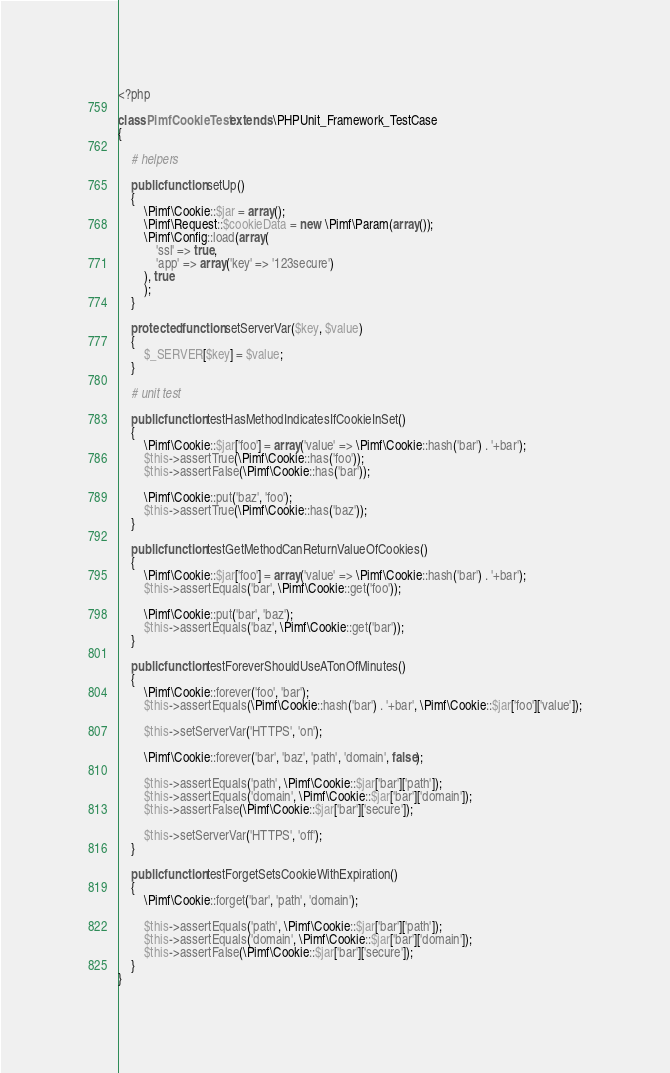Convert code to text. <code><loc_0><loc_0><loc_500><loc_500><_PHP_><?php

class PimfCookieTest extends \PHPUnit_Framework_TestCase
{

    # helpers

    public function setUp()
    {
        \Pimf\Cookie::$jar = array();
        \Pimf\Request::$cookieData = new \Pimf\Param(array());
        \Pimf\Config::load(array(
            'ssl' => true,
            'app' => array('key' => '123secure')
        ), true
        );
    }

    protected function setServerVar($key, $value)
    {
        $_SERVER[$key] = $value;
    }

    # unit test

    public function testHasMethodIndicatesIfCookieInSet()
    {
        \Pimf\Cookie::$jar['foo'] = array('value' => \Pimf\Cookie::hash('bar') . '+bar');
        $this->assertTrue(\Pimf\Cookie::has('foo'));
        $this->assertFalse(\Pimf\Cookie::has('bar'));

        \Pimf\Cookie::put('baz', 'foo');
        $this->assertTrue(\Pimf\Cookie::has('baz'));
    }

    public function testGetMethodCanReturnValueOfCookies()
    {
        \Pimf\Cookie::$jar['foo'] = array('value' => \Pimf\Cookie::hash('bar') . '+bar');
        $this->assertEquals('bar', \Pimf\Cookie::get('foo'));

        \Pimf\Cookie::put('bar', 'baz');
        $this->assertEquals('baz', \Pimf\Cookie::get('bar'));
    }

    public function testForeverShouldUseATonOfMinutes()
    {
        \Pimf\Cookie::forever('foo', 'bar');
        $this->assertEquals(\Pimf\Cookie::hash('bar') . '+bar', \Pimf\Cookie::$jar['foo']['value']);

        $this->setServerVar('HTTPS', 'on');

        \Pimf\Cookie::forever('bar', 'baz', 'path', 'domain', false);

        $this->assertEquals('path', \Pimf\Cookie::$jar['bar']['path']);
        $this->assertEquals('domain', \Pimf\Cookie::$jar['bar']['domain']);
        $this->assertFalse(\Pimf\Cookie::$jar['bar']['secure']);

        $this->setServerVar('HTTPS', 'off');
    }

    public function testForgetSetsCookieWithExpiration()
    {
        \Pimf\Cookie::forget('bar', 'path', 'domain');

        $this->assertEquals('path', \Pimf\Cookie::$jar['bar']['path']);
        $this->assertEquals('domain', \Pimf\Cookie::$jar['bar']['domain']);
        $this->assertFalse(\Pimf\Cookie::$jar['bar']['secure']);
    }
}</code> 